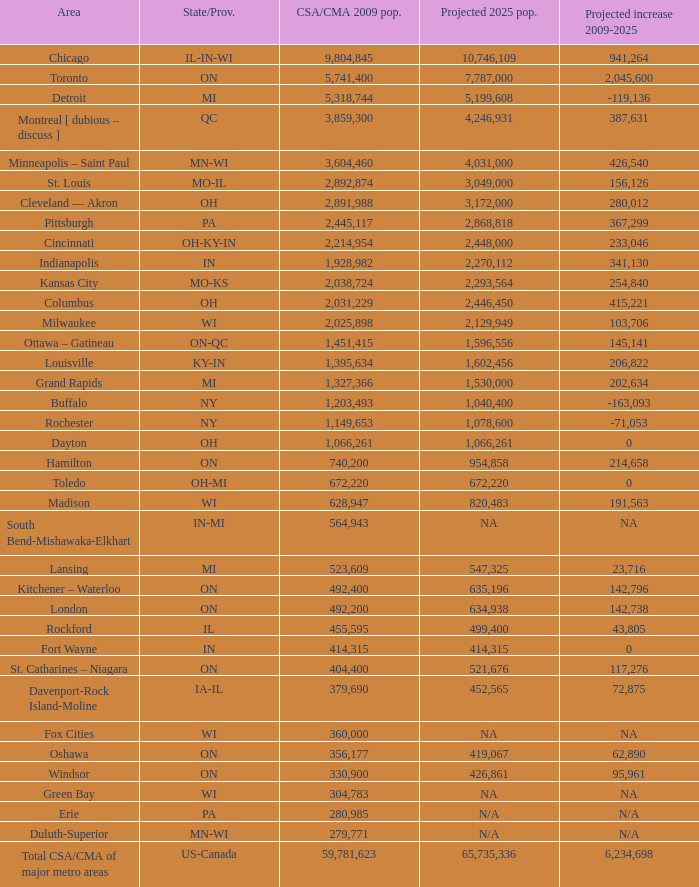What's the projected population of IN-MI? NA. 